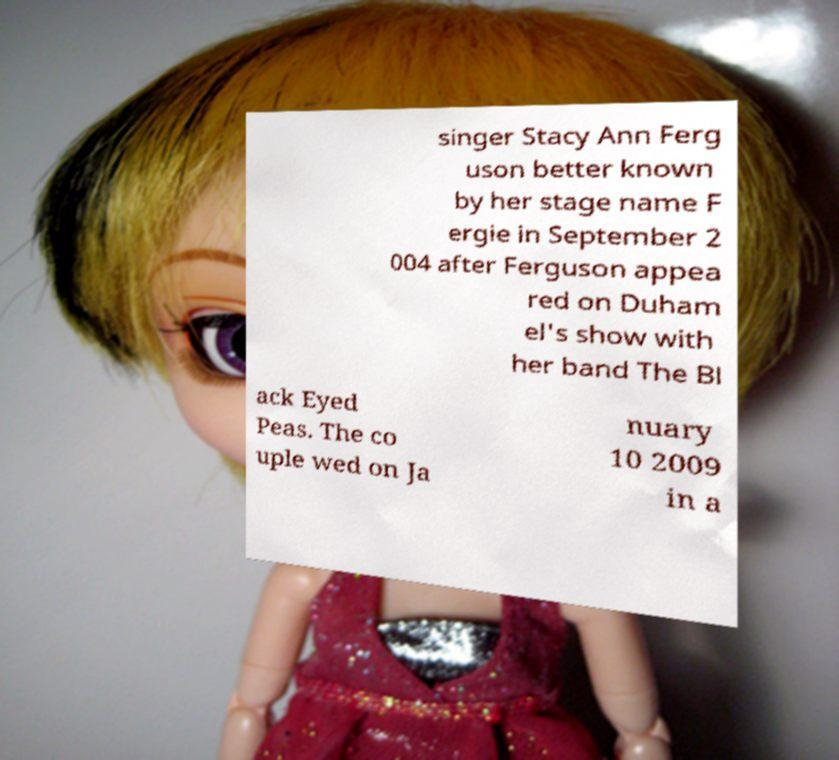For documentation purposes, I need the text within this image transcribed. Could you provide that? singer Stacy Ann Ferg uson better known by her stage name F ergie in September 2 004 after Ferguson appea red on Duham el's show with her band The Bl ack Eyed Peas. The co uple wed on Ja nuary 10 2009 in a 